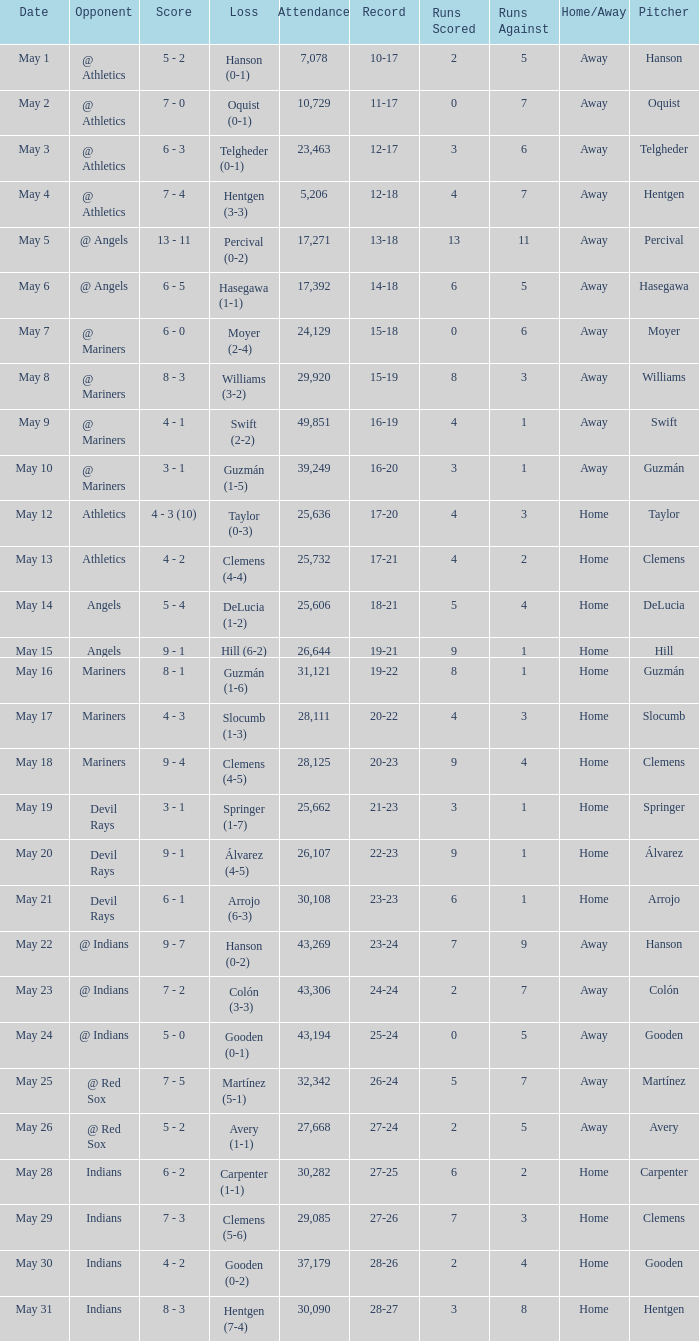When the record is 16-20 and attendance is greater than 32,342, what is the score? 3 - 1. 